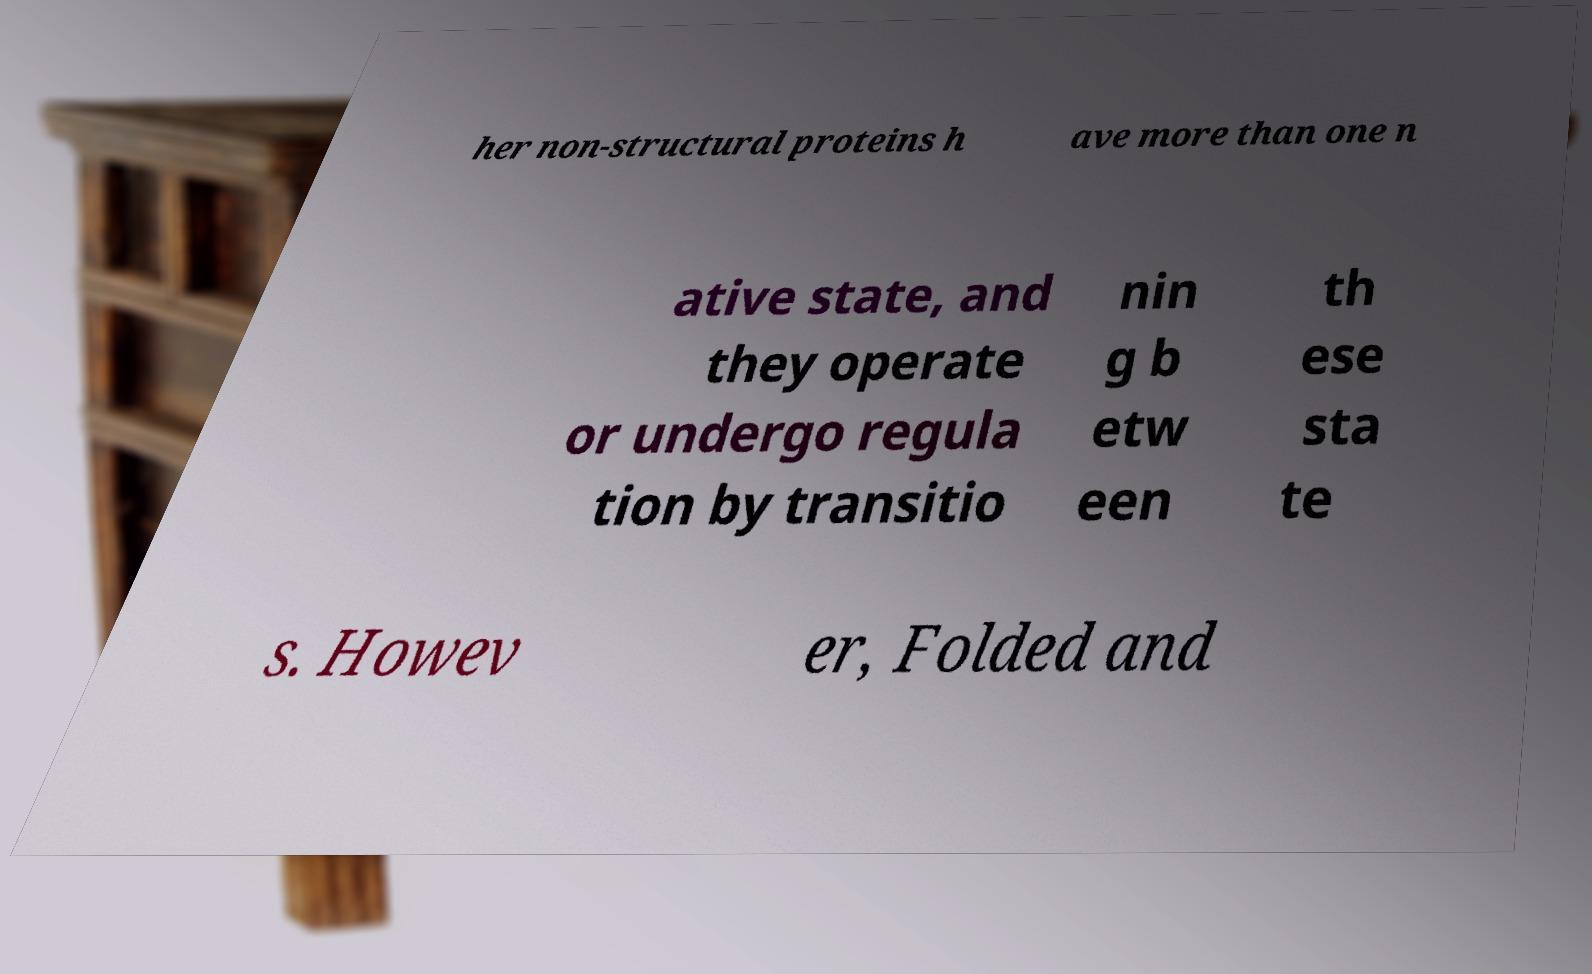Please read and relay the text visible in this image. What does it say? her non-structural proteins h ave more than one n ative state, and they operate or undergo regula tion by transitio nin g b etw een th ese sta te s. Howev er, Folded and 